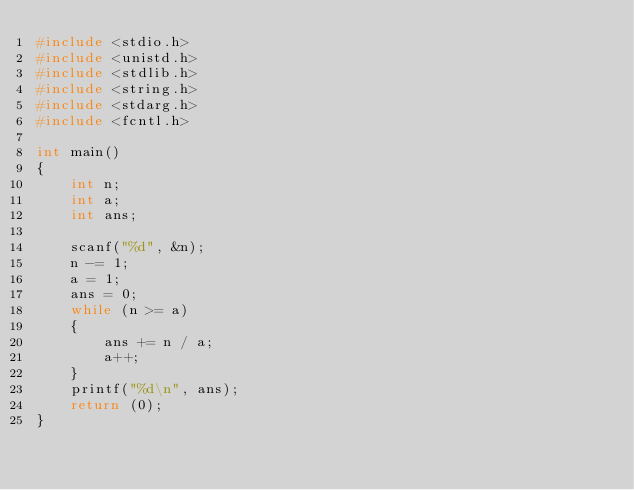Convert code to text. <code><loc_0><loc_0><loc_500><loc_500><_C_>#include <stdio.h>
#include <unistd.h>
#include <stdlib.h>
#include <string.h>
#include <stdarg.h>
#include <fcntl.h>

int main()
{
	int n;
	int a;
	int ans;
	
	scanf("%d", &n);
	n -= 1;
	a = 1;
	ans = 0;
	while (n >= a)
	{
		ans += n / a;
		a++;
	}
	printf("%d\n", ans);
	return (0);
}</code> 